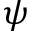Convert formula to latex. <formula><loc_0><loc_0><loc_500><loc_500>\psi</formula> 